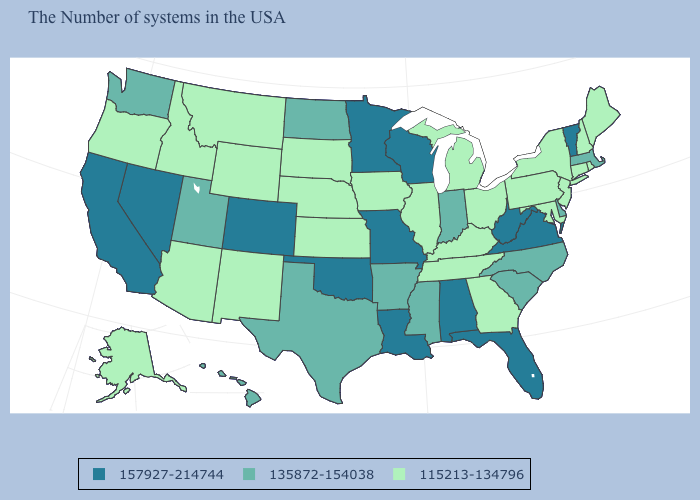What is the value of Virginia?
Be succinct. 157927-214744. Which states hav the highest value in the MidWest?
Answer briefly. Wisconsin, Missouri, Minnesota. What is the value of New York?
Give a very brief answer. 115213-134796. Name the states that have a value in the range 135872-154038?
Give a very brief answer. Massachusetts, Delaware, North Carolina, South Carolina, Indiana, Mississippi, Arkansas, Texas, North Dakota, Utah, Washington, Hawaii. Name the states that have a value in the range 135872-154038?
Give a very brief answer. Massachusetts, Delaware, North Carolina, South Carolina, Indiana, Mississippi, Arkansas, Texas, North Dakota, Utah, Washington, Hawaii. Among the states that border Wisconsin , which have the lowest value?
Keep it brief. Michigan, Illinois, Iowa. Does Virginia have the lowest value in the USA?
Quick response, please. No. Name the states that have a value in the range 115213-134796?
Answer briefly. Maine, Rhode Island, New Hampshire, Connecticut, New York, New Jersey, Maryland, Pennsylvania, Ohio, Georgia, Michigan, Kentucky, Tennessee, Illinois, Iowa, Kansas, Nebraska, South Dakota, Wyoming, New Mexico, Montana, Arizona, Idaho, Oregon, Alaska. What is the value of Connecticut?
Keep it brief. 115213-134796. Which states have the lowest value in the USA?
Short answer required. Maine, Rhode Island, New Hampshire, Connecticut, New York, New Jersey, Maryland, Pennsylvania, Ohio, Georgia, Michigan, Kentucky, Tennessee, Illinois, Iowa, Kansas, Nebraska, South Dakota, Wyoming, New Mexico, Montana, Arizona, Idaho, Oregon, Alaska. Does Texas have the highest value in the South?
Quick response, please. No. What is the lowest value in states that border Oklahoma?
Answer briefly. 115213-134796. Which states hav the highest value in the West?
Give a very brief answer. Colorado, Nevada, California. What is the value of Michigan?
Write a very short answer. 115213-134796. Does Alabama have the same value as Nevada?
Write a very short answer. Yes. 